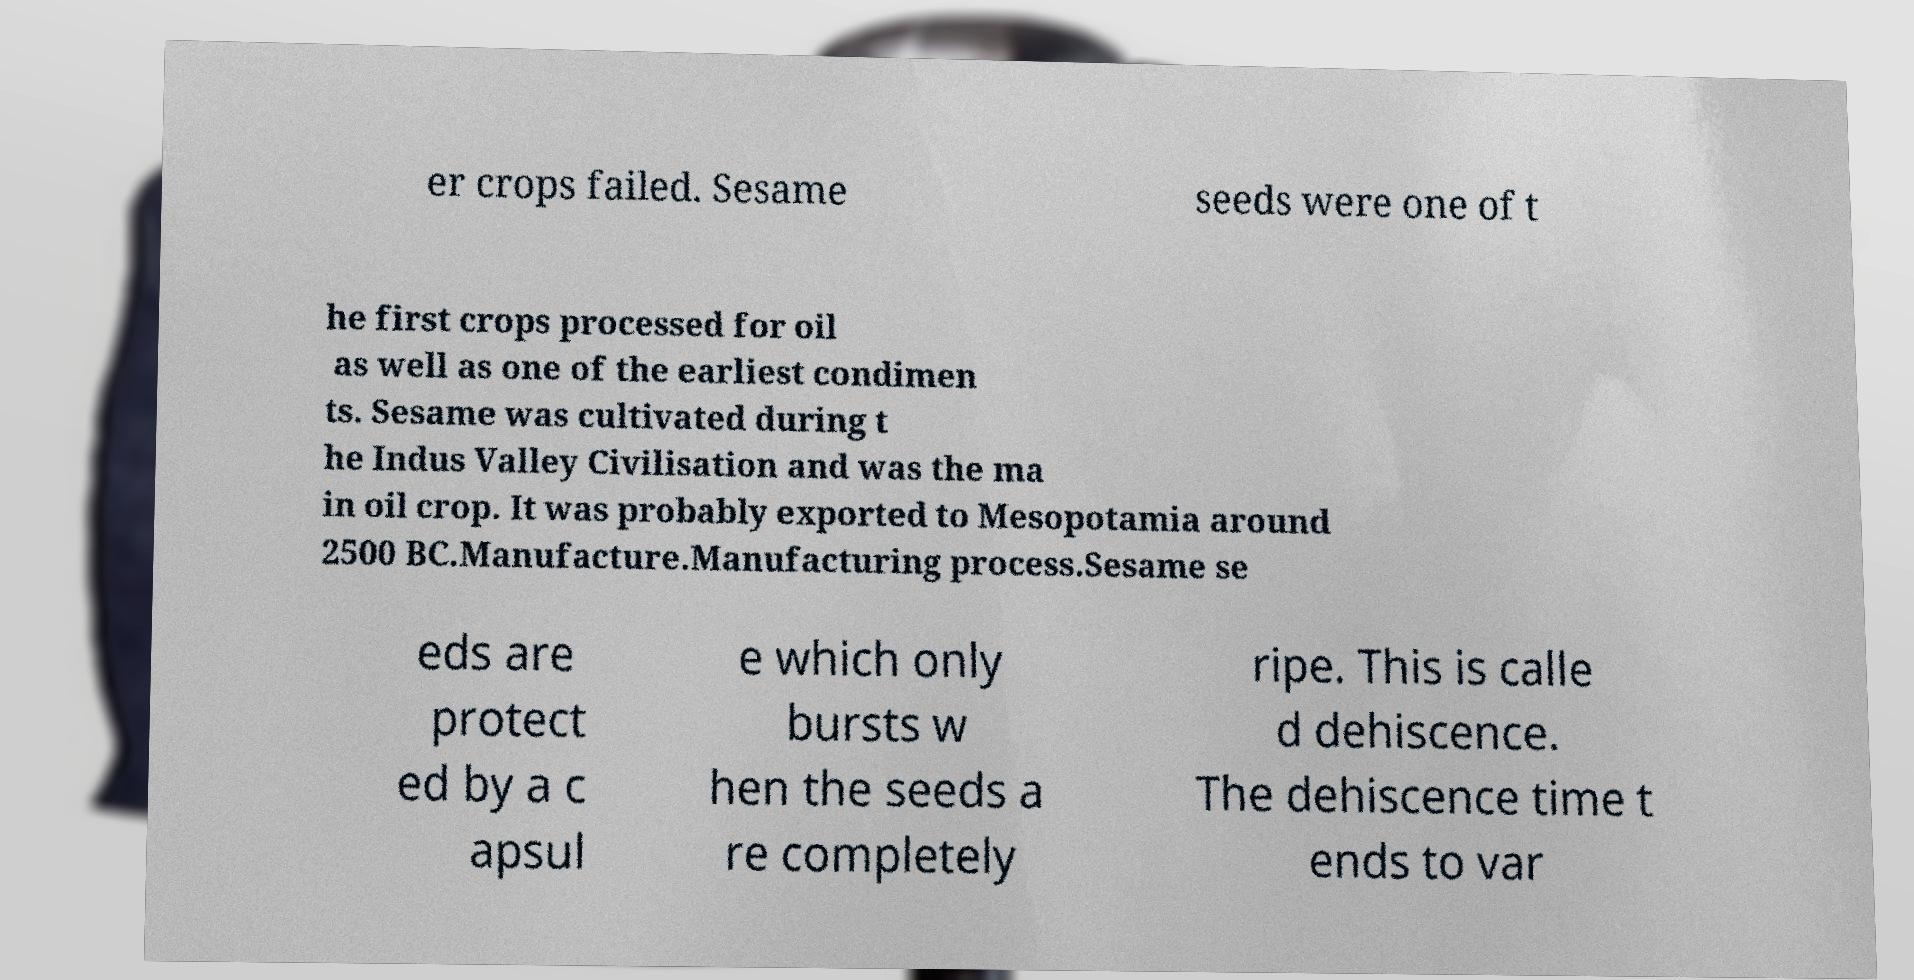There's text embedded in this image that I need extracted. Can you transcribe it verbatim? er crops failed. Sesame seeds were one of t he first crops processed for oil as well as one of the earliest condimen ts. Sesame was cultivated during t he Indus Valley Civilisation and was the ma in oil crop. It was probably exported to Mesopotamia around 2500 BC.Manufacture.Manufacturing process.Sesame se eds are protect ed by a c apsul e which only bursts w hen the seeds a re completely ripe. This is calle d dehiscence. The dehiscence time t ends to var 